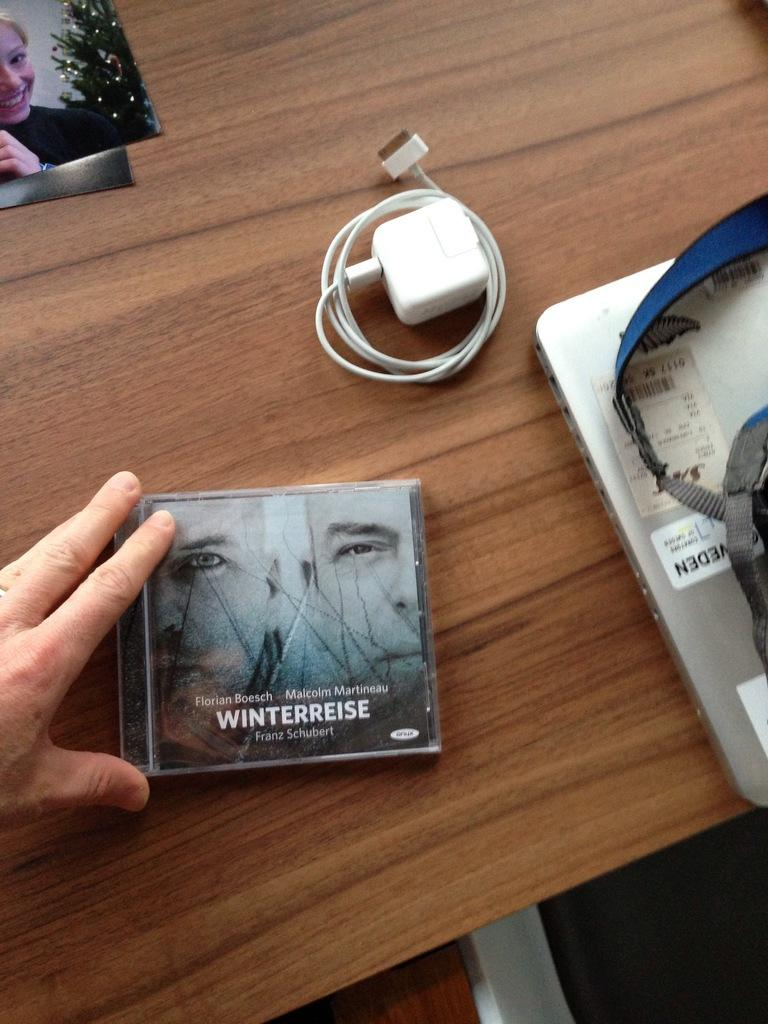What piece of furniture is present in the image? There is a table in the image. What electronic device is on the table? There is a laptop on the table. What else is on the table besides the laptop? There is a bag, a charger, and a photo on the table. What type of secretary is sitting next to the table in the image? There is no secretary present in the image; it only shows a table with a laptop, bag, charger, and photo. 